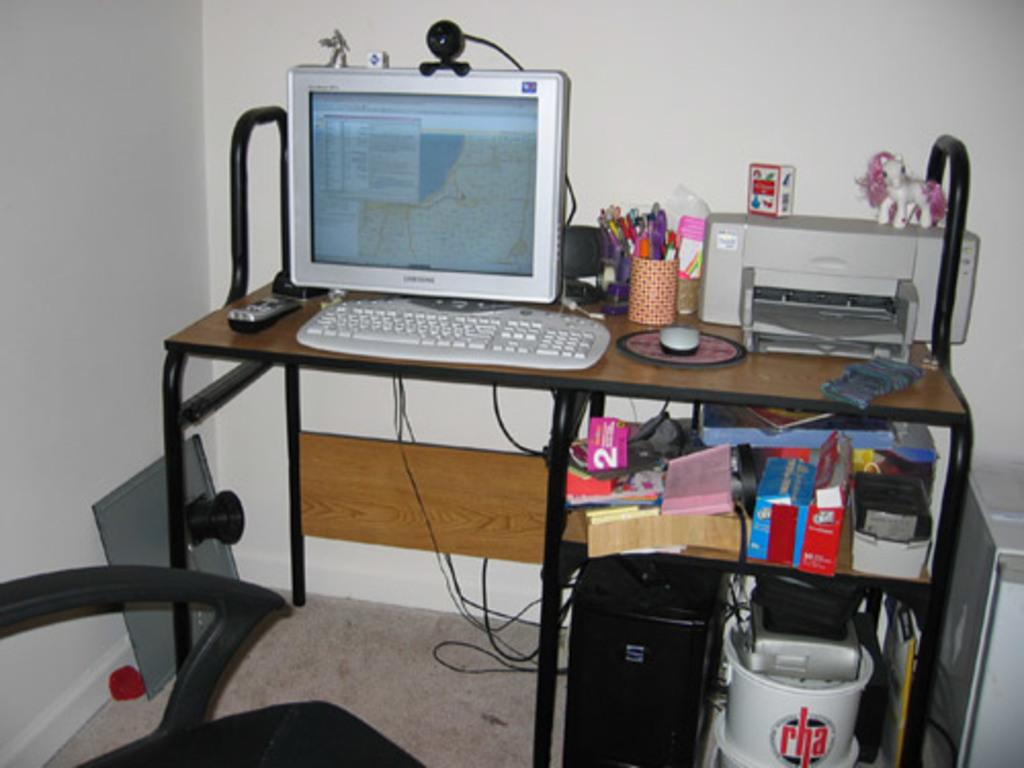What electronic device is on the table in the image? There is a computer on the table in the image. What is used for holding pens on the table? There is a pen stand on the table. What other office equipment is on the table? There is a printer on the table. Can you see any device for video communication? Yes, there is a webcam visible. What is stored on the shelf of the table? There are boxes on a shelf of the table. What color are the walls in the image? The walls in the image are white. What type of ground is visible in the image? There is no ground visible in the image; it is an indoor setting with a table and electronic devices. 